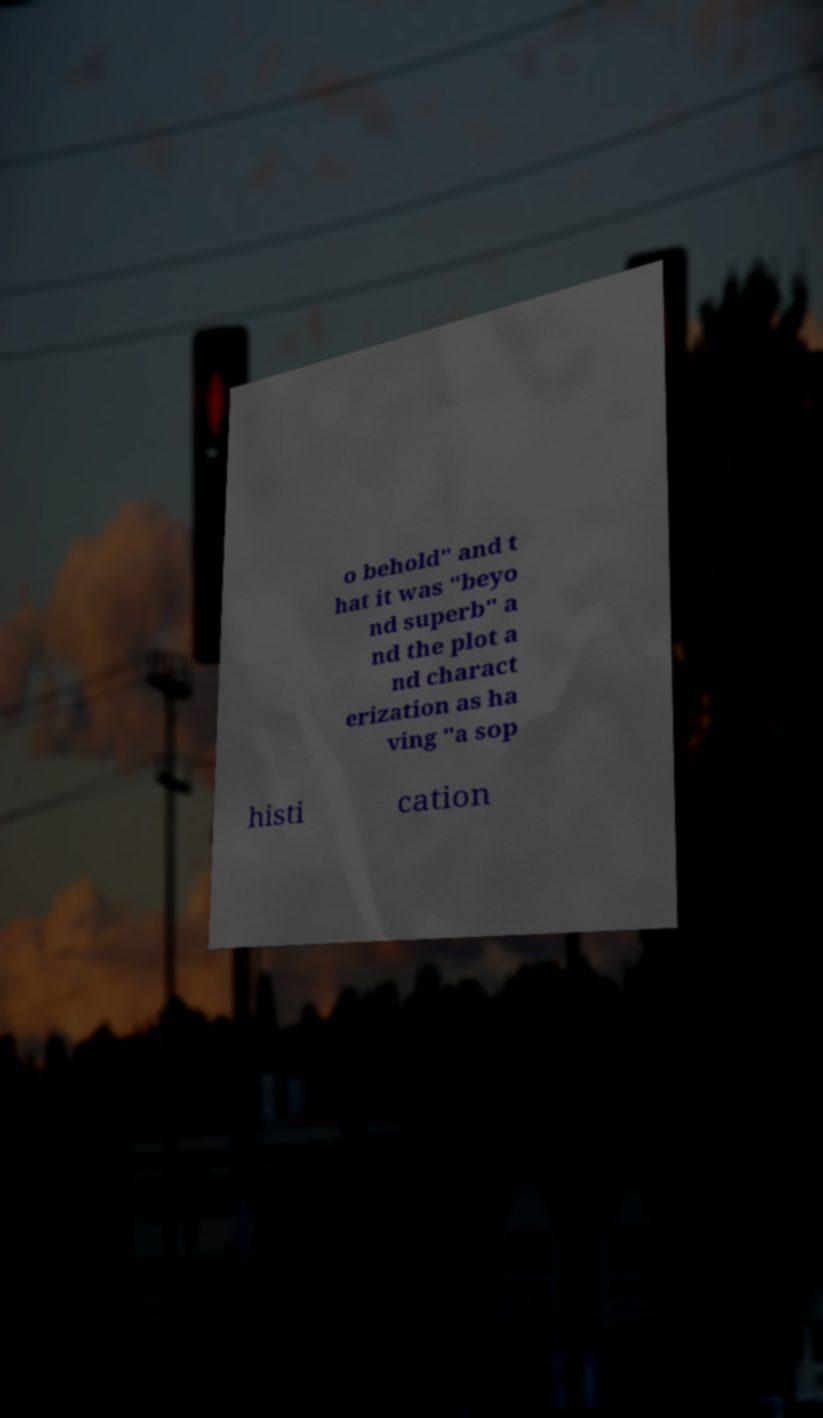I need the written content from this picture converted into text. Can you do that? o behold" and t hat it was "beyo nd superb" a nd the plot a nd charact erization as ha ving "a sop histi cation 